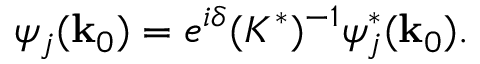<formula> <loc_0><loc_0><loc_500><loc_500>\psi _ { j } ( { k } _ { 0 } ) = e ^ { i \delta } ( K ^ { * } ) ^ { - 1 } \psi _ { j } ^ { * } ( { k } _ { 0 } ) .</formula> 